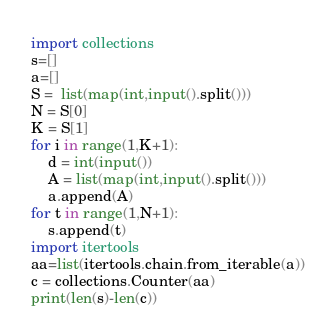Convert code to text. <code><loc_0><loc_0><loc_500><loc_500><_Python_>import collections
s=[]
a=[]
S =  list(map(int,input().split()))
N = S[0]
K = S[1]
for i in range(1,K+1):
    d = int(input())
    A = list(map(int,input().split()))
    a.append(A)
for t in range(1,N+1):
    s.append(t)
import itertools
aa=list(itertools.chain.from_iterable(a))
c = collections.Counter(aa)
print(len(s)-len(c))</code> 